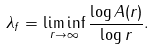Convert formula to latex. <formula><loc_0><loc_0><loc_500><loc_500>\lambda _ { f } = \liminf _ { r \to \infty } \frac { \log A ( r ) } { \log r } .</formula> 